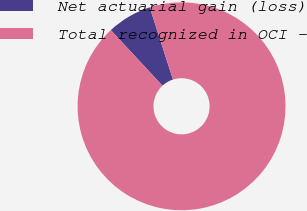Convert chart to OTSL. <chart><loc_0><loc_0><loc_500><loc_500><pie_chart><fcel>Net actuarial gain (loss)<fcel>Total recognized in OCI -<nl><fcel>6.96%<fcel>93.04%<nl></chart> 